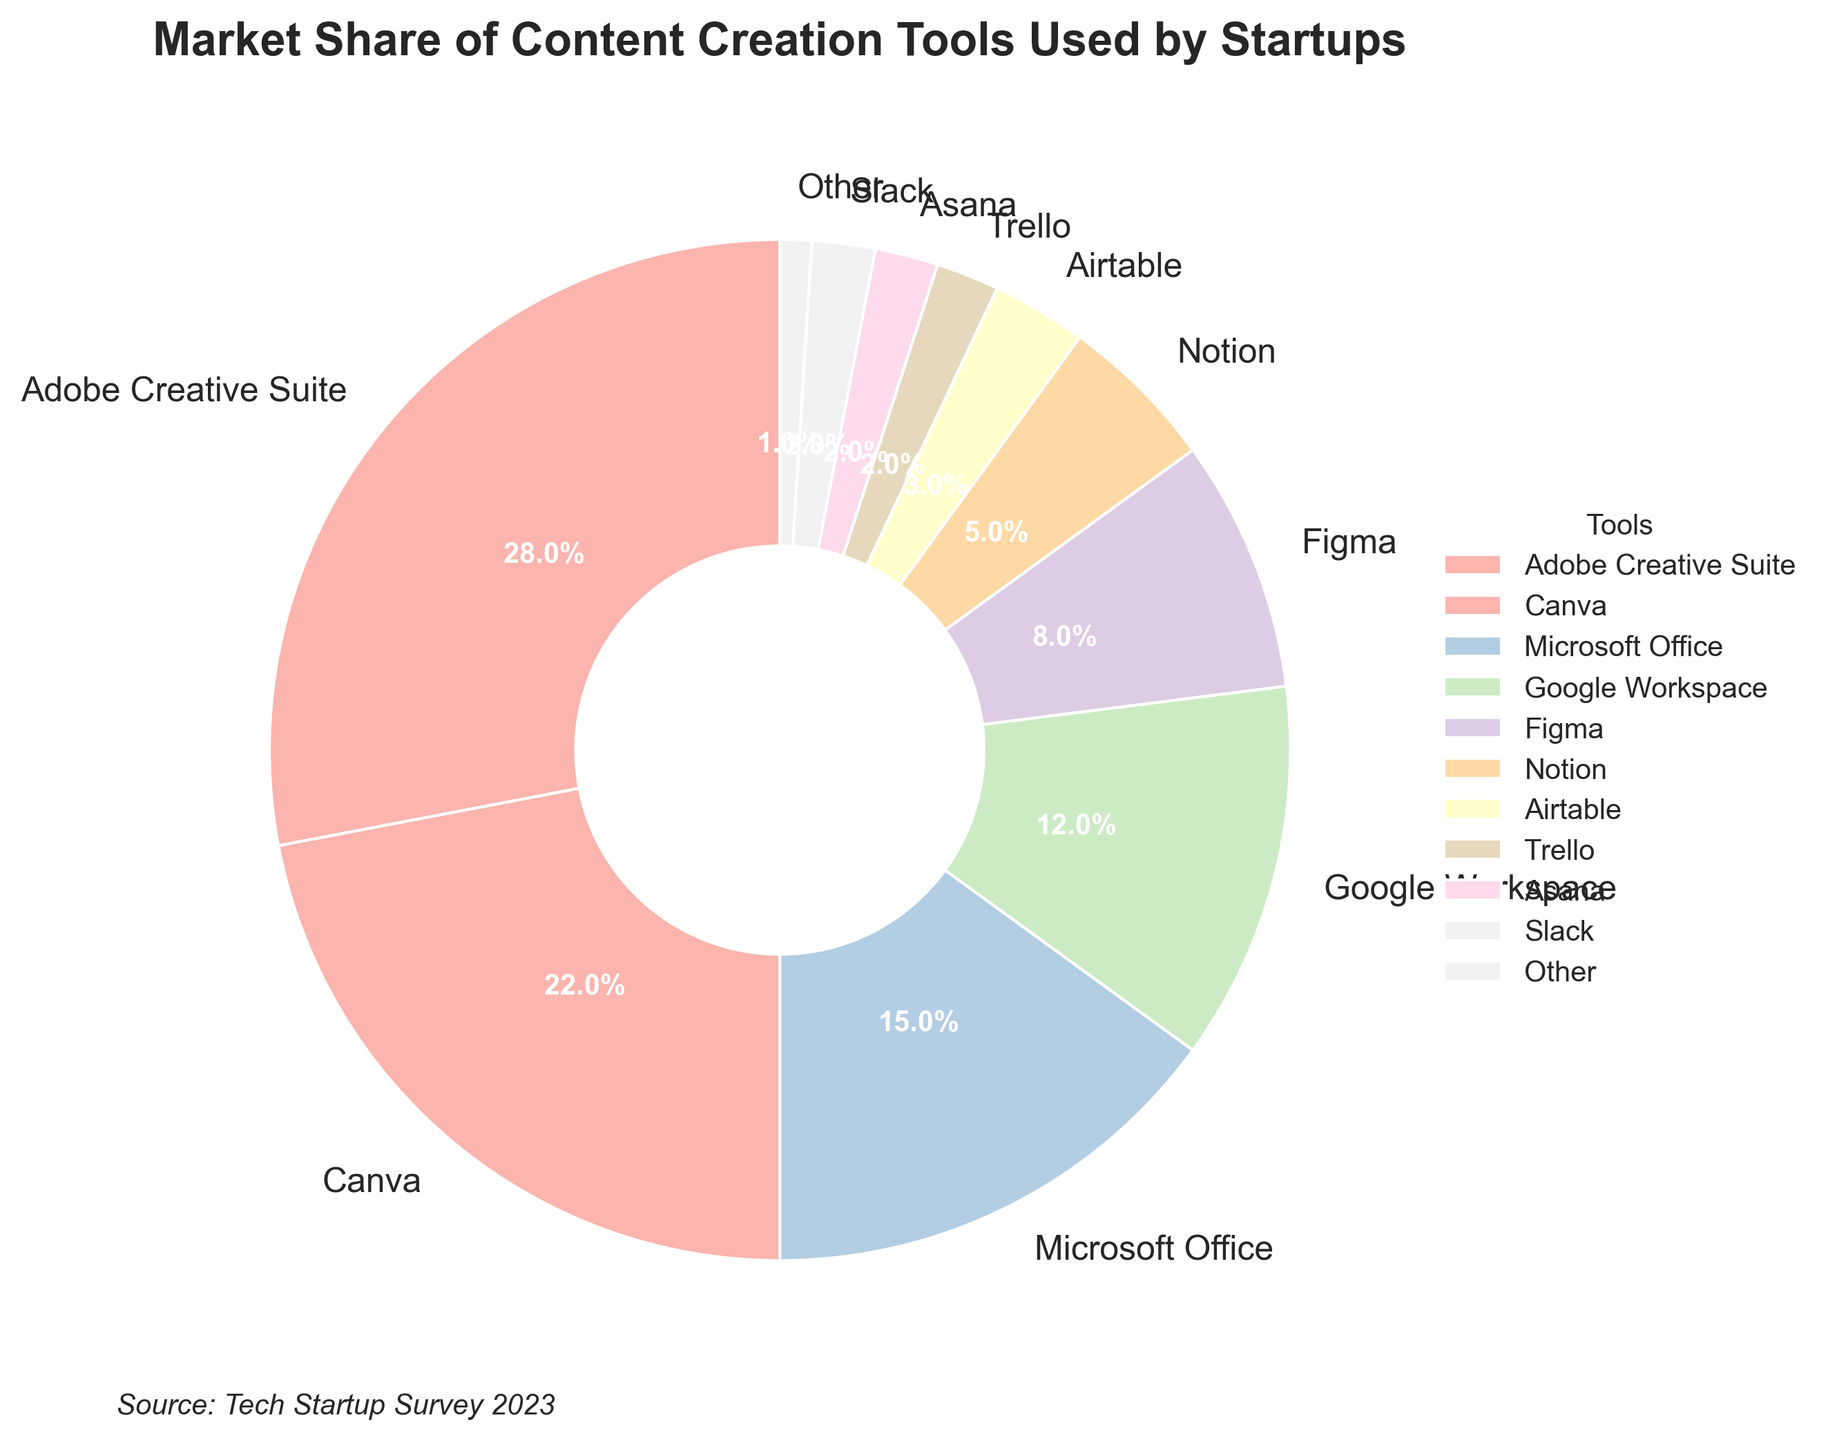Which content creation tool has the largest market share among startups? Identify the slice with the biggest percentage on the pie chart; it represents Adobe Creative Suite at 28%.
Answer: Adobe Creative Suite Which three tools have the smallest market share? Look for the slices with the smallest percentages, which are for Trello, Asana, and Slack, each at 2%.
Answer: Trello, Asana, Slack What is the combined market share of Notion and Airtable? Add the percentages of Notion (5%) and Airtable (3%), resulting in a total of 5% + 3% = 8%.
Answer: 8% Is Google's market share larger than Microsoft's? Compare Google Workspace’s 12% with Microsoft Office’s 15%; Microsoft Office's share is larger.
Answer: No By how much does Canva's market share exceed that of Figma? Subtract Figma’s market share (8%) from Canva’s (22%), resulting in 22% - 8% = 14%.
Answer: 14% Is the market share of "Other" tools more or less than Trello's market share? Compare the percentages for "Other" (1%) and Trello (2%); Trello's share is greater.
Answer: Less What percentage of the market do the top two tools (Adobe Creative Suite and Canva) hold together? Add Adobe Creative Suite's 28% and Canva's 22%, resulting in 28% + 22% = 50%.
Answer: 50% Which tool has a market share same as Slack? Both Asana and Slack have a market share of 2%.
Answer: Asana Which slice has a light pinkish color in the pie chart? Look for the visual representation where colors are used; matching the description to Canva's slice.
Answer: Canva 